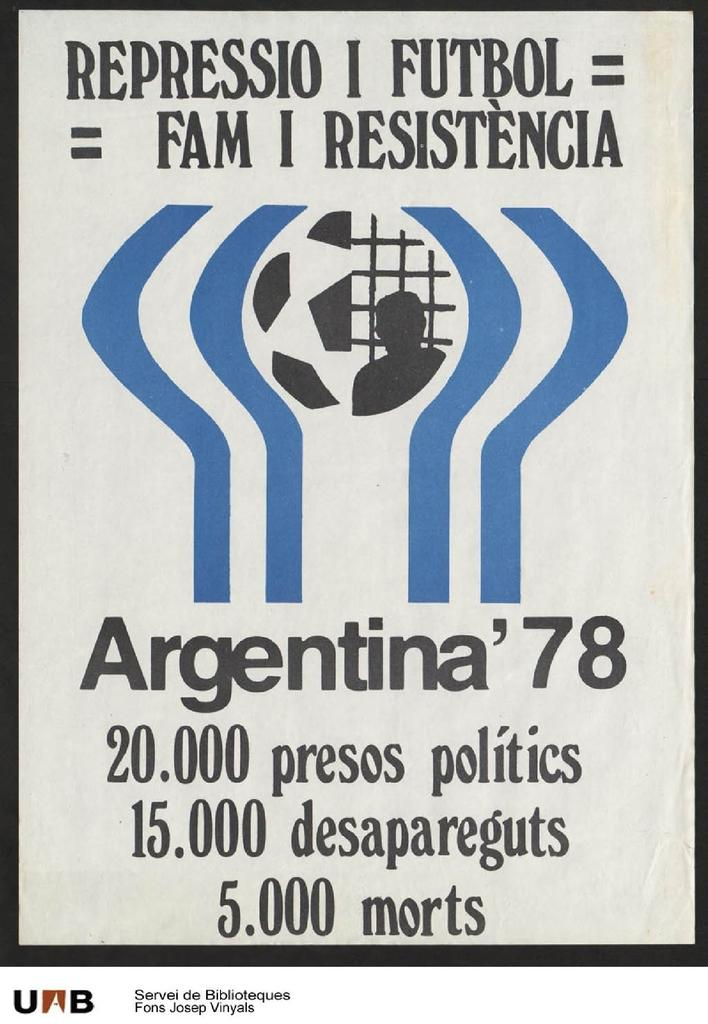<image>
Create a compact narrative representing the image presented. A poster with Argentina 78 written on it and a blue and black picture. 